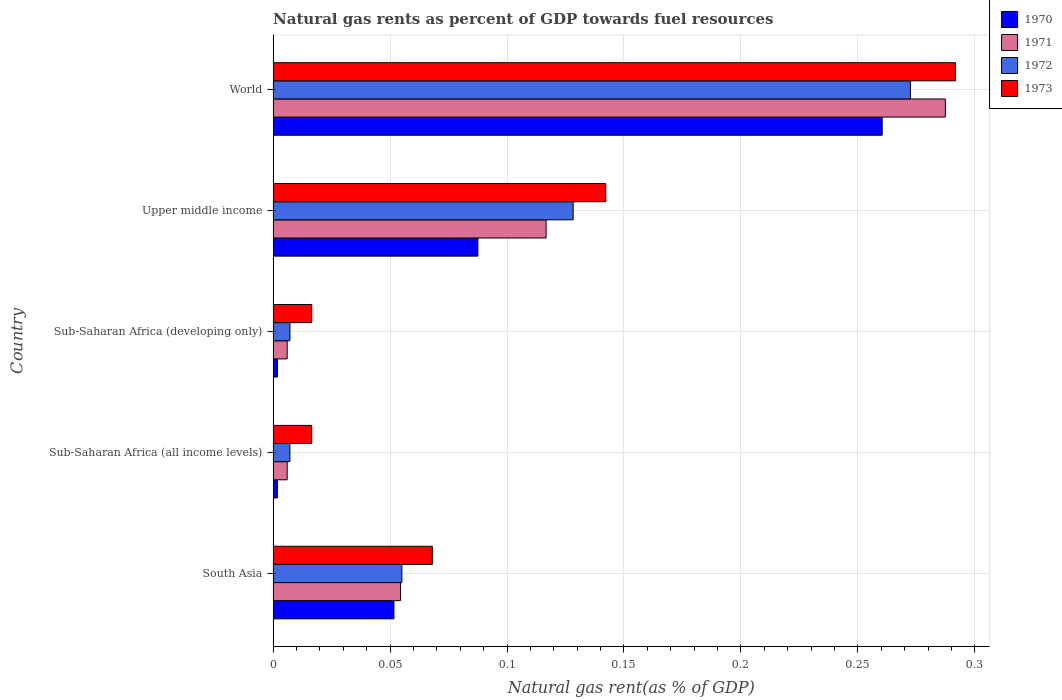How many different coloured bars are there?
Offer a terse response. 4. How many groups of bars are there?
Offer a terse response. 5. Are the number of bars per tick equal to the number of legend labels?
Give a very brief answer. Yes. How many bars are there on the 1st tick from the bottom?
Your response must be concise. 4. What is the label of the 2nd group of bars from the top?
Give a very brief answer. Upper middle income. In how many cases, is the number of bars for a given country not equal to the number of legend labels?
Make the answer very short. 0. What is the natural gas rent in 1970 in South Asia?
Keep it short and to the point. 0.05. Across all countries, what is the maximum natural gas rent in 1972?
Your answer should be compact. 0.27. Across all countries, what is the minimum natural gas rent in 1970?
Provide a succinct answer. 0. In which country was the natural gas rent in 1972 minimum?
Give a very brief answer. Sub-Saharan Africa (all income levels). What is the total natural gas rent in 1973 in the graph?
Keep it short and to the point. 0.54. What is the difference between the natural gas rent in 1970 in South Asia and that in World?
Ensure brevity in your answer.  -0.21. What is the difference between the natural gas rent in 1973 in World and the natural gas rent in 1970 in Upper middle income?
Offer a terse response. 0.2. What is the average natural gas rent in 1973 per country?
Your answer should be very brief. 0.11. What is the difference between the natural gas rent in 1973 and natural gas rent in 1970 in South Asia?
Make the answer very short. 0.02. In how many countries, is the natural gas rent in 1971 greater than 0.29 %?
Keep it short and to the point. 0. What is the ratio of the natural gas rent in 1971 in South Asia to that in Sub-Saharan Africa (all income levels)?
Your answer should be very brief. 9.07. What is the difference between the highest and the second highest natural gas rent in 1970?
Make the answer very short. 0.17. What is the difference between the highest and the lowest natural gas rent in 1972?
Your answer should be very brief. 0.27. In how many countries, is the natural gas rent in 1972 greater than the average natural gas rent in 1972 taken over all countries?
Offer a very short reply. 2. What does the 1st bar from the top in World represents?
Give a very brief answer. 1973. What does the 3rd bar from the bottom in Sub-Saharan Africa (developing only) represents?
Your response must be concise. 1972. Is it the case that in every country, the sum of the natural gas rent in 1971 and natural gas rent in 1972 is greater than the natural gas rent in 1970?
Ensure brevity in your answer.  Yes. How many countries are there in the graph?
Give a very brief answer. 5. Are the values on the major ticks of X-axis written in scientific E-notation?
Offer a terse response. No. Does the graph contain any zero values?
Keep it short and to the point. No. Where does the legend appear in the graph?
Offer a very short reply. Top right. How are the legend labels stacked?
Ensure brevity in your answer.  Vertical. What is the title of the graph?
Make the answer very short. Natural gas rents as percent of GDP towards fuel resources. Does "1975" appear as one of the legend labels in the graph?
Your response must be concise. No. What is the label or title of the X-axis?
Keep it short and to the point. Natural gas rent(as % of GDP). What is the Natural gas rent(as % of GDP) in 1970 in South Asia?
Your response must be concise. 0.05. What is the Natural gas rent(as % of GDP) in 1971 in South Asia?
Your answer should be compact. 0.05. What is the Natural gas rent(as % of GDP) of 1972 in South Asia?
Ensure brevity in your answer.  0.06. What is the Natural gas rent(as % of GDP) of 1973 in South Asia?
Provide a short and direct response. 0.07. What is the Natural gas rent(as % of GDP) of 1970 in Sub-Saharan Africa (all income levels)?
Keep it short and to the point. 0. What is the Natural gas rent(as % of GDP) in 1971 in Sub-Saharan Africa (all income levels)?
Provide a succinct answer. 0.01. What is the Natural gas rent(as % of GDP) of 1972 in Sub-Saharan Africa (all income levels)?
Make the answer very short. 0.01. What is the Natural gas rent(as % of GDP) of 1973 in Sub-Saharan Africa (all income levels)?
Provide a succinct answer. 0.02. What is the Natural gas rent(as % of GDP) of 1970 in Sub-Saharan Africa (developing only)?
Your answer should be compact. 0. What is the Natural gas rent(as % of GDP) in 1971 in Sub-Saharan Africa (developing only)?
Your answer should be compact. 0.01. What is the Natural gas rent(as % of GDP) in 1972 in Sub-Saharan Africa (developing only)?
Provide a short and direct response. 0.01. What is the Natural gas rent(as % of GDP) of 1973 in Sub-Saharan Africa (developing only)?
Your answer should be compact. 0.02. What is the Natural gas rent(as % of GDP) of 1970 in Upper middle income?
Give a very brief answer. 0.09. What is the Natural gas rent(as % of GDP) of 1971 in Upper middle income?
Offer a very short reply. 0.12. What is the Natural gas rent(as % of GDP) in 1972 in Upper middle income?
Keep it short and to the point. 0.13. What is the Natural gas rent(as % of GDP) of 1973 in Upper middle income?
Keep it short and to the point. 0.14. What is the Natural gas rent(as % of GDP) in 1970 in World?
Ensure brevity in your answer.  0.26. What is the Natural gas rent(as % of GDP) of 1971 in World?
Your response must be concise. 0.29. What is the Natural gas rent(as % of GDP) of 1972 in World?
Ensure brevity in your answer.  0.27. What is the Natural gas rent(as % of GDP) of 1973 in World?
Give a very brief answer. 0.29. Across all countries, what is the maximum Natural gas rent(as % of GDP) in 1970?
Keep it short and to the point. 0.26. Across all countries, what is the maximum Natural gas rent(as % of GDP) in 1971?
Give a very brief answer. 0.29. Across all countries, what is the maximum Natural gas rent(as % of GDP) in 1972?
Give a very brief answer. 0.27. Across all countries, what is the maximum Natural gas rent(as % of GDP) of 1973?
Offer a terse response. 0.29. Across all countries, what is the minimum Natural gas rent(as % of GDP) in 1970?
Provide a short and direct response. 0. Across all countries, what is the minimum Natural gas rent(as % of GDP) in 1971?
Your answer should be very brief. 0.01. Across all countries, what is the minimum Natural gas rent(as % of GDP) in 1972?
Offer a very short reply. 0.01. Across all countries, what is the minimum Natural gas rent(as % of GDP) in 1973?
Offer a very short reply. 0.02. What is the total Natural gas rent(as % of GDP) of 1970 in the graph?
Ensure brevity in your answer.  0.4. What is the total Natural gas rent(as % of GDP) of 1971 in the graph?
Keep it short and to the point. 0.47. What is the total Natural gas rent(as % of GDP) of 1972 in the graph?
Offer a terse response. 0.47. What is the total Natural gas rent(as % of GDP) of 1973 in the graph?
Your answer should be very brief. 0.54. What is the difference between the Natural gas rent(as % of GDP) in 1970 in South Asia and that in Sub-Saharan Africa (all income levels)?
Provide a short and direct response. 0.05. What is the difference between the Natural gas rent(as % of GDP) of 1971 in South Asia and that in Sub-Saharan Africa (all income levels)?
Provide a succinct answer. 0.05. What is the difference between the Natural gas rent(as % of GDP) in 1972 in South Asia and that in Sub-Saharan Africa (all income levels)?
Provide a short and direct response. 0.05. What is the difference between the Natural gas rent(as % of GDP) in 1973 in South Asia and that in Sub-Saharan Africa (all income levels)?
Offer a very short reply. 0.05. What is the difference between the Natural gas rent(as % of GDP) in 1970 in South Asia and that in Sub-Saharan Africa (developing only)?
Your answer should be compact. 0.05. What is the difference between the Natural gas rent(as % of GDP) of 1971 in South Asia and that in Sub-Saharan Africa (developing only)?
Give a very brief answer. 0.05. What is the difference between the Natural gas rent(as % of GDP) in 1972 in South Asia and that in Sub-Saharan Africa (developing only)?
Make the answer very short. 0.05. What is the difference between the Natural gas rent(as % of GDP) in 1973 in South Asia and that in Sub-Saharan Africa (developing only)?
Keep it short and to the point. 0.05. What is the difference between the Natural gas rent(as % of GDP) in 1970 in South Asia and that in Upper middle income?
Offer a terse response. -0.04. What is the difference between the Natural gas rent(as % of GDP) in 1971 in South Asia and that in Upper middle income?
Ensure brevity in your answer.  -0.06. What is the difference between the Natural gas rent(as % of GDP) in 1972 in South Asia and that in Upper middle income?
Offer a terse response. -0.07. What is the difference between the Natural gas rent(as % of GDP) in 1973 in South Asia and that in Upper middle income?
Offer a very short reply. -0.07. What is the difference between the Natural gas rent(as % of GDP) in 1970 in South Asia and that in World?
Ensure brevity in your answer.  -0.21. What is the difference between the Natural gas rent(as % of GDP) of 1971 in South Asia and that in World?
Make the answer very short. -0.23. What is the difference between the Natural gas rent(as % of GDP) in 1972 in South Asia and that in World?
Offer a very short reply. -0.22. What is the difference between the Natural gas rent(as % of GDP) of 1973 in South Asia and that in World?
Ensure brevity in your answer.  -0.22. What is the difference between the Natural gas rent(as % of GDP) of 1970 in Sub-Saharan Africa (all income levels) and that in Sub-Saharan Africa (developing only)?
Keep it short and to the point. -0. What is the difference between the Natural gas rent(as % of GDP) of 1973 in Sub-Saharan Africa (all income levels) and that in Sub-Saharan Africa (developing only)?
Your answer should be compact. -0. What is the difference between the Natural gas rent(as % of GDP) in 1970 in Sub-Saharan Africa (all income levels) and that in Upper middle income?
Your response must be concise. -0.09. What is the difference between the Natural gas rent(as % of GDP) of 1971 in Sub-Saharan Africa (all income levels) and that in Upper middle income?
Make the answer very short. -0.11. What is the difference between the Natural gas rent(as % of GDP) in 1972 in Sub-Saharan Africa (all income levels) and that in Upper middle income?
Provide a short and direct response. -0.12. What is the difference between the Natural gas rent(as % of GDP) in 1973 in Sub-Saharan Africa (all income levels) and that in Upper middle income?
Ensure brevity in your answer.  -0.13. What is the difference between the Natural gas rent(as % of GDP) of 1970 in Sub-Saharan Africa (all income levels) and that in World?
Provide a succinct answer. -0.26. What is the difference between the Natural gas rent(as % of GDP) in 1971 in Sub-Saharan Africa (all income levels) and that in World?
Ensure brevity in your answer.  -0.28. What is the difference between the Natural gas rent(as % of GDP) in 1972 in Sub-Saharan Africa (all income levels) and that in World?
Make the answer very short. -0.27. What is the difference between the Natural gas rent(as % of GDP) of 1973 in Sub-Saharan Africa (all income levels) and that in World?
Offer a terse response. -0.28. What is the difference between the Natural gas rent(as % of GDP) in 1970 in Sub-Saharan Africa (developing only) and that in Upper middle income?
Keep it short and to the point. -0.09. What is the difference between the Natural gas rent(as % of GDP) of 1971 in Sub-Saharan Africa (developing only) and that in Upper middle income?
Give a very brief answer. -0.11. What is the difference between the Natural gas rent(as % of GDP) of 1972 in Sub-Saharan Africa (developing only) and that in Upper middle income?
Your answer should be very brief. -0.12. What is the difference between the Natural gas rent(as % of GDP) of 1973 in Sub-Saharan Africa (developing only) and that in Upper middle income?
Offer a very short reply. -0.13. What is the difference between the Natural gas rent(as % of GDP) in 1970 in Sub-Saharan Africa (developing only) and that in World?
Offer a terse response. -0.26. What is the difference between the Natural gas rent(as % of GDP) of 1971 in Sub-Saharan Africa (developing only) and that in World?
Provide a short and direct response. -0.28. What is the difference between the Natural gas rent(as % of GDP) in 1972 in Sub-Saharan Africa (developing only) and that in World?
Offer a very short reply. -0.27. What is the difference between the Natural gas rent(as % of GDP) in 1973 in Sub-Saharan Africa (developing only) and that in World?
Your answer should be very brief. -0.28. What is the difference between the Natural gas rent(as % of GDP) of 1970 in Upper middle income and that in World?
Your response must be concise. -0.17. What is the difference between the Natural gas rent(as % of GDP) in 1971 in Upper middle income and that in World?
Your answer should be compact. -0.17. What is the difference between the Natural gas rent(as % of GDP) of 1972 in Upper middle income and that in World?
Your response must be concise. -0.14. What is the difference between the Natural gas rent(as % of GDP) of 1973 in Upper middle income and that in World?
Give a very brief answer. -0.15. What is the difference between the Natural gas rent(as % of GDP) of 1970 in South Asia and the Natural gas rent(as % of GDP) of 1971 in Sub-Saharan Africa (all income levels)?
Offer a very short reply. 0.05. What is the difference between the Natural gas rent(as % of GDP) of 1970 in South Asia and the Natural gas rent(as % of GDP) of 1972 in Sub-Saharan Africa (all income levels)?
Make the answer very short. 0.04. What is the difference between the Natural gas rent(as % of GDP) in 1970 in South Asia and the Natural gas rent(as % of GDP) in 1973 in Sub-Saharan Africa (all income levels)?
Your answer should be very brief. 0.04. What is the difference between the Natural gas rent(as % of GDP) of 1971 in South Asia and the Natural gas rent(as % of GDP) of 1972 in Sub-Saharan Africa (all income levels)?
Provide a short and direct response. 0.05. What is the difference between the Natural gas rent(as % of GDP) of 1971 in South Asia and the Natural gas rent(as % of GDP) of 1973 in Sub-Saharan Africa (all income levels)?
Your answer should be very brief. 0.04. What is the difference between the Natural gas rent(as % of GDP) of 1972 in South Asia and the Natural gas rent(as % of GDP) of 1973 in Sub-Saharan Africa (all income levels)?
Keep it short and to the point. 0.04. What is the difference between the Natural gas rent(as % of GDP) in 1970 in South Asia and the Natural gas rent(as % of GDP) in 1971 in Sub-Saharan Africa (developing only)?
Provide a succinct answer. 0.05. What is the difference between the Natural gas rent(as % of GDP) in 1970 in South Asia and the Natural gas rent(as % of GDP) in 1972 in Sub-Saharan Africa (developing only)?
Offer a very short reply. 0.04. What is the difference between the Natural gas rent(as % of GDP) of 1970 in South Asia and the Natural gas rent(as % of GDP) of 1973 in Sub-Saharan Africa (developing only)?
Provide a short and direct response. 0.04. What is the difference between the Natural gas rent(as % of GDP) of 1971 in South Asia and the Natural gas rent(as % of GDP) of 1972 in Sub-Saharan Africa (developing only)?
Give a very brief answer. 0.05. What is the difference between the Natural gas rent(as % of GDP) in 1971 in South Asia and the Natural gas rent(as % of GDP) in 1973 in Sub-Saharan Africa (developing only)?
Offer a terse response. 0.04. What is the difference between the Natural gas rent(as % of GDP) in 1972 in South Asia and the Natural gas rent(as % of GDP) in 1973 in Sub-Saharan Africa (developing only)?
Provide a succinct answer. 0.04. What is the difference between the Natural gas rent(as % of GDP) of 1970 in South Asia and the Natural gas rent(as % of GDP) of 1971 in Upper middle income?
Provide a succinct answer. -0.07. What is the difference between the Natural gas rent(as % of GDP) of 1970 in South Asia and the Natural gas rent(as % of GDP) of 1972 in Upper middle income?
Provide a succinct answer. -0.08. What is the difference between the Natural gas rent(as % of GDP) in 1970 in South Asia and the Natural gas rent(as % of GDP) in 1973 in Upper middle income?
Make the answer very short. -0.09. What is the difference between the Natural gas rent(as % of GDP) of 1971 in South Asia and the Natural gas rent(as % of GDP) of 1972 in Upper middle income?
Provide a short and direct response. -0.07. What is the difference between the Natural gas rent(as % of GDP) in 1971 in South Asia and the Natural gas rent(as % of GDP) in 1973 in Upper middle income?
Your answer should be very brief. -0.09. What is the difference between the Natural gas rent(as % of GDP) of 1972 in South Asia and the Natural gas rent(as % of GDP) of 1973 in Upper middle income?
Your response must be concise. -0.09. What is the difference between the Natural gas rent(as % of GDP) in 1970 in South Asia and the Natural gas rent(as % of GDP) in 1971 in World?
Offer a very short reply. -0.24. What is the difference between the Natural gas rent(as % of GDP) in 1970 in South Asia and the Natural gas rent(as % of GDP) in 1972 in World?
Make the answer very short. -0.22. What is the difference between the Natural gas rent(as % of GDP) of 1970 in South Asia and the Natural gas rent(as % of GDP) of 1973 in World?
Keep it short and to the point. -0.24. What is the difference between the Natural gas rent(as % of GDP) of 1971 in South Asia and the Natural gas rent(as % of GDP) of 1972 in World?
Provide a short and direct response. -0.22. What is the difference between the Natural gas rent(as % of GDP) of 1971 in South Asia and the Natural gas rent(as % of GDP) of 1973 in World?
Ensure brevity in your answer.  -0.24. What is the difference between the Natural gas rent(as % of GDP) of 1972 in South Asia and the Natural gas rent(as % of GDP) of 1973 in World?
Give a very brief answer. -0.24. What is the difference between the Natural gas rent(as % of GDP) of 1970 in Sub-Saharan Africa (all income levels) and the Natural gas rent(as % of GDP) of 1971 in Sub-Saharan Africa (developing only)?
Provide a short and direct response. -0. What is the difference between the Natural gas rent(as % of GDP) of 1970 in Sub-Saharan Africa (all income levels) and the Natural gas rent(as % of GDP) of 1972 in Sub-Saharan Africa (developing only)?
Provide a succinct answer. -0.01. What is the difference between the Natural gas rent(as % of GDP) in 1970 in Sub-Saharan Africa (all income levels) and the Natural gas rent(as % of GDP) in 1973 in Sub-Saharan Africa (developing only)?
Your response must be concise. -0.01. What is the difference between the Natural gas rent(as % of GDP) of 1971 in Sub-Saharan Africa (all income levels) and the Natural gas rent(as % of GDP) of 1972 in Sub-Saharan Africa (developing only)?
Your response must be concise. -0. What is the difference between the Natural gas rent(as % of GDP) of 1971 in Sub-Saharan Africa (all income levels) and the Natural gas rent(as % of GDP) of 1973 in Sub-Saharan Africa (developing only)?
Provide a succinct answer. -0.01. What is the difference between the Natural gas rent(as % of GDP) in 1972 in Sub-Saharan Africa (all income levels) and the Natural gas rent(as % of GDP) in 1973 in Sub-Saharan Africa (developing only)?
Your answer should be compact. -0.01. What is the difference between the Natural gas rent(as % of GDP) in 1970 in Sub-Saharan Africa (all income levels) and the Natural gas rent(as % of GDP) in 1971 in Upper middle income?
Offer a very short reply. -0.11. What is the difference between the Natural gas rent(as % of GDP) in 1970 in Sub-Saharan Africa (all income levels) and the Natural gas rent(as % of GDP) in 1972 in Upper middle income?
Keep it short and to the point. -0.13. What is the difference between the Natural gas rent(as % of GDP) of 1970 in Sub-Saharan Africa (all income levels) and the Natural gas rent(as % of GDP) of 1973 in Upper middle income?
Make the answer very short. -0.14. What is the difference between the Natural gas rent(as % of GDP) of 1971 in Sub-Saharan Africa (all income levels) and the Natural gas rent(as % of GDP) of 1972 in Upper middle income?
Your response must be concise. -0.12. What is the difference between the Natural gas rent(as % of GDP) in 1971 in Sub-Saharan Africa (all income levels) and the Natural gas rent(as % of GDP) in 1973 in Upper middle income?
Provide a short and direct response. -0.14. What is the difference between the Natural gas rent(as % of GDP) in 1972 in Sub-Saharan Africa (all income levels) and the Natural gas rent(as % of GDP) in 1973 in Upper middle income?
Give a very brief answer. -0.14. What is the difference between the Natural gas rent(as % of GDP) in 1970 in Sub-Saharan Africa (all income levels) and the Natural gas rent(as % of GDP) in 1971 in World?
Your response must be concise. -0.29. What is the difference between the Natural gas rent(as % of GDP) in 1970 in Sub-Saharan Africa (all income levels) and the Natural gas rent(as % of GDP) in 1972 in World?
Your answer should be very brief. -0.27. What is the difference between the Natural gas rent(as % of GDP) in 1970 in Sub-Saharan Africa (all income levels) and the Natural gas rent(as % of GDP) in 1973 in World?
Give a very brief answer. -0.29. What is the difference between the Natural gas rent(as % of GDP) of 1971 in Sub-Saharan Africa (all income levels) and the Natural gas rent(as % of GDP) of 1972 in World?
Provide a succinct answer. -0.27. What is the difference between the Natural gas rent(as % of GDP) in 1971 in Sub-Saharan Africa (all income levels) and the Natural gas rent(as % of GDP) in 1973 in World?
Offer a very short reply. -0.29. What is the difference between the Natural gas rent(as % of GDP) of 1972 in Sub-Saharan Africa (all income levels) and the Natural gas rent(as % of GDP) of 1973 in World?
Your response must be concise. -0.28. What is the difference between the Natural gas rent(as % of GDP) of 1970 in Sub-Saharan Africa (developing only) and the Natural gas rent(as % of GDP) of 1971 in Upper middle income?
Give a very brief answer. -0.11. What is the difference between the Natural gas rent(as % of GDP) in 1970 in Sub-Saharan Africa (developing only) and the Natural gas rent(as % of GDP) in 1972 in Upper middle income?
Offer a terse response. -0.13. What is the difference between the Natural gas rent(as % of GDP) in 1970 in Sub-Saharan Africa (developing only) and the Natural gas rent(as % of GDP) in 1973 in Upper middle income?
Offer a very short reply. -0.14. What is the difference between the Natural gas rent(as % of GDP) in 1971 in Sub-Saharan Africa (developing only) and the Natural gas rent(as % of GDP) in 1972 in Upper middle income?
Ensure brevity in your answer.  -0.12. What is the difference between the Natural gas rent(as % of GDP) of 1971 in Sub-Saharan Africa (developing only) and the Natural gas rent(as % of GDP) of 1973 in Upper middle income?
Offer a very short reply. -0.14. What is the difference between the Natural gas rent(as % of GDP) in 1972 in Sub-Saharan Africa (developing only) and the Natural gas rent(as % of GDP) in 1973 in Upper middle income?
Your answer should be very brief. -0.14. What is the difference between the Natural gas rent(as % of GDP) in 1970 in Sub-Saharan Africa (developing only) and the Natural gas rent(as % of GDP) in 1971 in World?
Offer a very short reply. -0.29. What is the difference between the Natural gas rent(as % of GDP) in 1970 in Sub-Saharan Africa (developing only) and the Natural gas rent(as % of GDP) in 1972 in World?
Provide a short and direct response. -0.27. What is the difference between the Natural gas rent(as % of GDP) of 1970 in Sub-Saharan Africa (developing only) and the Natural gas rent(as % of GDP) of 1973 in World?
Offer a terse response. -0.29. What is the difference between the Natural gas rent(as % of GDP) in 1971 in Sub-Saharan Africa (developing only) and the Natural gas rent(as % of GDP) in 1972 in World?
Provide a short and direct response. -0.27. What is the difference between the Natural gas rent(as % of GDP) in 1971 in Sub-Saharan Africa (developing only) and the Natural gas rent(as % of GDP) in 1973 in World?
Provide a short and direct response. -0.29. What is the difference between the Natural gas rent(as % of GDP) in 1972 in Sub-Saharan Africa (developing only) and the Natural gas rent(as % of GDP) in 1973 in World?
Keep it short and to the point. -0.28. What is the difference between the Natural gas rent(as % of GDP) of 1970 in Upper middle income and the Natural gas rent(as % of GDP) of 1971 in World?
Your answer should be compact. -0.2. What is the difference between the Natural gas rent(as % of GDP) in 1970 in Upper middle income and the Natural gas rent(as % of GDP) in 1972 in World?
Your answer should be compact. -0.18. What is the difference between the Natural gas rent(as % of GDP) of 1970 in Upper middle income and the Natural gas rent(as % of GDP) of 1973 in World?
Your response must be concise. -0.2. What is the difference between the Natural gas rent(as % of GDP) in 1971 in Upper middle income and the Natural gas rent(as % of GDP) in 1972 in World?
Your response must be concise. -0.16. What is the difference between the Natural gas rent(as % of GDP) of 1971 in Upper middle income and the Natural gas rent(as % of GDP) of 1973 in World?
Your answer should be compact. -0.17. What is the difference between the Natural gas rent(as % of GDP) of 1972 in Upper middle income and the Natural gas rent(as % of GDP) of 1973 in World?
Offer a very short reply. -0.16. What is the average Natural gas rent(as % of GDP) in 1970 per country?
Offer a terse response. 0.08. What is the average Natural gas rent(as % of GDP) in 1971 per country?
Your answer should be very brief. 0.09. What is the average Natural gas rent(as % of GDP) in 1972 per country?
Your answer should be compact. 0.09. What is the average Natural gas rent(as % of GDP) of 1973 per country?
Provide a succinct answer. 0.11. What is the difference between the Natural gas rent(as % of GDP) of 1970 and Natural gas rent(as % of GDP) of 1971 in South Asia?
Your response must be concise. -0. What is the difference between the Natural gas rent(as % of GDP) of 1970 and Natural gas rent(as % of GDP) of 1972 in South Asia?
Your response must be concise. -0. What is the difference between the Natural gas rent(as % of GDP) in 1970 and Natural gas rent(as % of GDP) in 1973 in South Asia?
Ensure brevity in your answer.  -0.02. What is the difference between the Natural gas rent(as % of GDP) in 1971 and Natural gas rent(as % of GDP) in 1972 in South Asia?
Offer a very short reply. -0. What is the difference between the Natural gas rent(as % of GDP) in 1971 and Natural gas rent(as % of GDP) in 1973 in South Asia?
Ensure brevity in your answer.  -0.01. What is the difference between the Natural gas rent(as % of GDP) in 1972 and Natural gas rent(as % of GDP) in 1973 in South Asia?
Offer a terse response. -0.01. What is the difference between the Natural gas rent(as % of GDP) of 1970 and Natural gas rent(as % of GDP) of 1971 in Sub-Saharan Africa (all income levels)?
Provide a short and direct response. -0. What is the difference between the Natural gas rent(as % of GDP) of 1970 and Natural gas rent(as % of GDP) of 1972 in Sub-Saharan Africa (all income levels)?
Give a very brief answer. -0.01. What is the difference between the Natural gas rent(as % of GDP) of 1970 and Natural gas rent(as % of GDP) of 1973 in Sub-Saharan Africa (all income levels)?
Offer a very short reply. -0.01. What is the difference between the Natural gas rent(as % of GDP) of 1971 and Natural gas rent(as % of GDP) of 1972 in Sub-Saharan Africa (all income levels)?
Your answer should be very brief. -0. What is the difference between the Natural gas rent(as % of GDP) in 1971 and Natural gas rent(as % of GDP) in 1973 in Sub-Saharan Africa (all income levels)?
Keep it short and to the point. -0.01. What is the difference between the Natural gas rent(as % of GDP) in 1972 and Natural gas rent(as % of GDP) in 1973 in Sub-Saharan Africa (all income levels)?
Your response must be concise. -0.01. What is the difference between the Natural gas rent(as % of GDP) in 1970 and Natural gas rent(as % of GDP) in 1971 in Sub-Saharan Africa (developing only)?
Provide a short and direct response. -0. What is the difference between the Natural gas rent(as % of GDP) of 1970 and Natural gas rent(as % of GDP) of 1972 in Sub-Saharan Africa (developing only)?
Your answer should be very brief. -0.01. What is the difference between the Natural gas rent(as % of GDP) in 1970 and Natural gas rent(as % of GDP) in 1973 in Sub-Saharan Africa (developing only)?
Your answer should be very brief. -0.01. What is the difference between the Natural gas rent(as % of GDP) in 1971 and Natural gas rent(as % of GDP) in 1972 in Sub-Saharan Africa (developing only)?
Give a very brief answer. -0. What is the difference between the Natural gas rent(as % of GDP) in 1971 and Natural gas rent(as % of GDP) in 1973 in Sub-Saharan Africa (developing only)?
Ensure brevity in your answer.  -0.01. What is the difference between the Natural gas rent(as % of GDP) in 1972 and Natural gas rent(as % of GDP) in 1973 in Sub-Saharan Africa (developing only)?
Ensure brevity in your answer.  -0.01. What is the difference between the Natural gas rent(as % of GDP) of 1970 and Natural gas rent(as % of GDP) of 1971 in Upper middle income?
Offer a very short reply. -0.03. What is the difference between the Natural gas rent(as % of GDP) of 1970 and Natural gas rent(as % of GDP) of 1972 in Upper middle income?
Make the answer very short. -0.04. What is the difference between the Natural gas rent(as % of GDP) of 1970 and Natural gas rent(as % of GDP) of 1973 in Upper middle income?
Provide a succinct answer. -0.05. What is the difference between the Natural gas rent(as % of GDP) of 1971 and Natural gas rent(as % of GDP) of 1972 in Upper middle income?
Provide a succinct answer. -0.01. What is the difference between the Natural gas rent(as % of GDP) in 1971 and Natural gas rent(as % of GDP) in 1973 in Upper middle income?
Your answer should be very brief. -0.03. What is the difference between the Natural gas rent(as % of GDP) of 1972 and Natural gas rent(as % of GDP) of 1973 in Upper middle income?
Ensure brevity in your answer.  -0.01. What is the difference between the Natural gas rent(as % of GDP) in 1970 and Natural gas rent(as % of GDP) in 1971 in World?
Keep it short and to the point. -0.03. What is the difference between the Natural gas rent(as % of GDP) in 1970 and Natural gas rent(as % of GDP) in 1972 in World?
Keep it short and to the point. -0.01. What is the difference between the Natural gas rent(as % of GDP) in 1970 and Natural gas rent(as % of GDP) in 1973 in World?
Give a very brief answer. -0.03. What is the difference between the Natural gas rent(as % of GDP) in 1971 and Natural gas rent(as % of GDP) in 1972 in World?
Offer a terse response. 0.01. What is the difference between the Natural gas rent(as % of GDP) in 1971 and Natural gas rent(as % of GDP) in 1973 in World?
Provide a succinct answer. -0. What is the difference between the Natural gas rent(as % of GDP) in 1972 and Natural gas rent(as % of GDP) in 1973 in World?
Your answer should be compact. -0.02. What is the ratio of the Natural gas rent(as % of GDP) of 1970 in South Asia to that in Sub-Saharan Africa (all income levels)?
Your answer should be very brief. 28.57. What is the ratio of the Natural gas rent(as % of GDP) of 1971 in South Asia to that in Sub-Saharan Africa (all income levels)?
Give a very brief answer. 9.07. What is the ratio of the Natural gas rent(as % of GDP) in 1972 in South Asia to that in Sub-Saharan Africa (all income levels)?
Offer a terse response. 7.67. What is the ratio of the Natural gas rent(as % of GDP) of 1973 in South Asia to that in Sub-Saharan Africa (all income levels)?
Provide a succinct answer. 4.13. What is the ratio of the Natural gas rent(as % of GDP) of 1970 in South Asia to that in Sub-Saharan Africa (developing only)?
Offer a very short reply. 28.53. What is the ratio of the Natural gas rent(as % of GDP) of 1971 in South Asia to that in Sub-Saharan Africa (developing only)?
Keep it short and to the point. 9.06. What is the ratio of the Natural gas rent(as % of GDP) in 1972 in South Asia to that in Sub-Saharan Africa (developing only)?
Keep it short and to the point. 7.66. What is the ratio of the Natural gas rent(as % of GDP) in 1973 in South Asia to that in Sub-Saharan Africa (developing only)?
Offer a very short reply. 4.12. What is the ratio of the Natural gas rent(as % of GDP) of 1970 in South Asia to that in Upper middle income?
Your answer should be very brief. 0.59. What is the ratio of the Natural gas rent(as % of GDP) in 1971 in South Asia to that in Upper middle income?
Provide a succinct answer. 0.47. What is the ratio of the Natural gas rent(as % of GDP) of 1972 in South Asia to that in Upper middle income?
Your answer should be compact. 0.43. What is the ratio of the Natural gas rent(as % of GDP) in 1973 in South Asia to that in Upper middle income?
Offer a terse response. 0.48. What is the ratio of the Natural gas rent(as % of GDP) of 1970 in South Asia to that in World?
Your response must be concise. 0.2. What is the ratio of the Natural gas rent(as % of GDP) in 1971 in South Asia to that in World?
Ensure brevity in your answer.  0.19. What is the ratio of the Natural gas rent(as % of GDP) in 1972 in South Asia to that in World?
Provide a succinct answer. 0.2. What is the ratio of the Natural gas rent(as % of GDP) in 1973 in South Asia to that in World?
Provide a short and direct response. 0.23. What is the ratio of the Natural gas rent(as % of GDP) in 1970 in Sub-Saharan Africa (all income levels) to that in Sub-Saharan Africa (developing only)?
Your answer should be compact. 1. What is the ratio of the Natural gas rent(as % of GDP) of 1971 in Sub-Saharan Africa (all income levels) to that in Sub-Saharan Africa (developing only)?
Keep it short and to the point. 1. What is the ratio of the Natural gas rent(as % of GDP) in 1972 in Sub-Saharan Africa (all income levels) to that in Sub-Saharan Africa (developing only)?
Offer a very short reply. 1. What is the ratio of the Natural gas rent(as % of GDP) in 1973 in Sub-Saharan Africa (all income levels) to that in Sub-Saharan Africa (developing only)?
Ensure brevity in your answer.  1. What is the ratio of the Natural gas rent(as % of GDP) in 1970 in Sub-Saharan Africa (all income levels) to that in Upper middle income?
Keep it short and to the point. 0.02. What is the ratio of the Natural gas rent(as % of GDP) of 1971 in Sub-Saharan Africa (all income levels) to that in Upper middle income?
Offer a very short reply. 0.05. What is the ratio of the Natural gas rent(as % of GDP) in 1972 in Sub-Saharan Africa (all income levels) to that in Upper middle income?
Your answer should be very brief. 0.06. What is the ratio of the Natural gas rent(as % of GDP) of 1973 in Sub-Saharan Africa (all income levels) to that in Upper middle income?
Make the answer very short. 0.12. What is the ratio of the Natural gas rent(as % of GDP) in 1970 in Sub-Saharan Africa (all income levels) to that in World?
Your answer should be very brief. 0.01. What is the ratio of the Natural gas rent(as % of GDP) of 1971 in Sub-Saharan Africa (all income levels) to that in World?
Provide a short and direct response. 0.02. What is the ratio of the Natural gas rent(as % of GDP) of 1972 in Sub-Saharan Africa (all income levels) to that in World?
Give a very brief answer. 0.03. What is the ratio of the Natural gas rent(as % of GDP) in 1973 in Sub-Saharan Africa (all income levels) to that in World?
Provide a short and direct response. 0.06. What is the ratio of the Natural gas rent(as % of GDP) of 1970 in Sub-Saharan Africa (developing only) to that in Upper middle income?
Provide a short and direct response. 0.02. What is the ratio of the Natural gas rent(as % of GDP) of 1971 in Sub-Saharan Africa (developing only) to that in Upper middle income?
Offer a very short reply. 0.05. What is the ratio of the Natural gas rent(as % of GDP) of 1972 in Sub-Saharan Africa (developing only) to that in Upper middle income?
Make the answer very short. 0.06. What is the ratio of the Natural gas rent(as % of GDP) of 1973 in Sub-Saharan Africa (developing only) to that in Upper middle income?
Provide a succinct answer. 0.12. What is the ratio of the Natural gas rent(as % of GDP) in 1970 in Sub-Saharan Africa (developing only) to that in World?
Provide a succinct answer. 0.01. What is the ratio of the Natural gas rent(as % of GDP) of 1971 in Sub-Saharan Africa (developing only) to that in World?
Provide a short and direct response. 0.02. What is the ratio of the Natural gas rent(as % of GDP) in 1972 in Sub-Saharan Africa (developing only) to that in World?
Ensure brevity in your answer.  0.03. What is the ratio of the Natural gas rent(as % of GDP) of 1973 in Sub-Saharan Africa (developing only) to that in World?
Give a very brief answer. 0.06. What is the ratio of the Natural gas rent(as % of GDP) of 1970 in Upper middle income to that in World?
Your answer should be very brief. 0.34. What is the ratio of the Natural gas rent(as % of GDP) of 1971 in Upper middle income to that in World?
Give a very brief answer. 0.41. What is the ratio of the Natural gas rent(as % of GDP) in 1972 in Upper middle income to that in World?
Provide a short and direct response. 0.47. What is the ratio of the Natural gas rent(as % of GDP) in 1973 in Upper middle income to that in World?
Ensure brevity in your answer.  0.49. What is the difference between the highest and the second highest Natural gas rent(as % of GDP) of 1970?
Your response must be concise. 0.17. What is the difference between the highest and the second highest Natural gas rent(as % of GDP) in 1971?
Provide a succinct answer. 0.17. What is the difference between the highest and the second highest Natural gas rent(as % of GDP) of 1972?
Make the answer very short. 0.14. What is the difference between the highest and the second highest Natural gas rent(as % of GDP) in 1973?
Ensure brevity in your answer.  0.15. What is the difference between the highest and the lowest Natural gas rent(as % of GDP) of 1970?
Provide a succinct answer. 0.26. What is the difference between the highest and the lowest Natural gas rent(as % of GDP) of 1971?
Ensure brevity in your answer.  0.28. What is the difference between the highest and the lowest Natural gas rent(as % of GDP) in 1972?
Provide a succinct answer. 0.27. What is the difference between the highest and the lowest Natural gas rent(as % of GDP) in 1973?
Offer a very short reply. 0.28. 